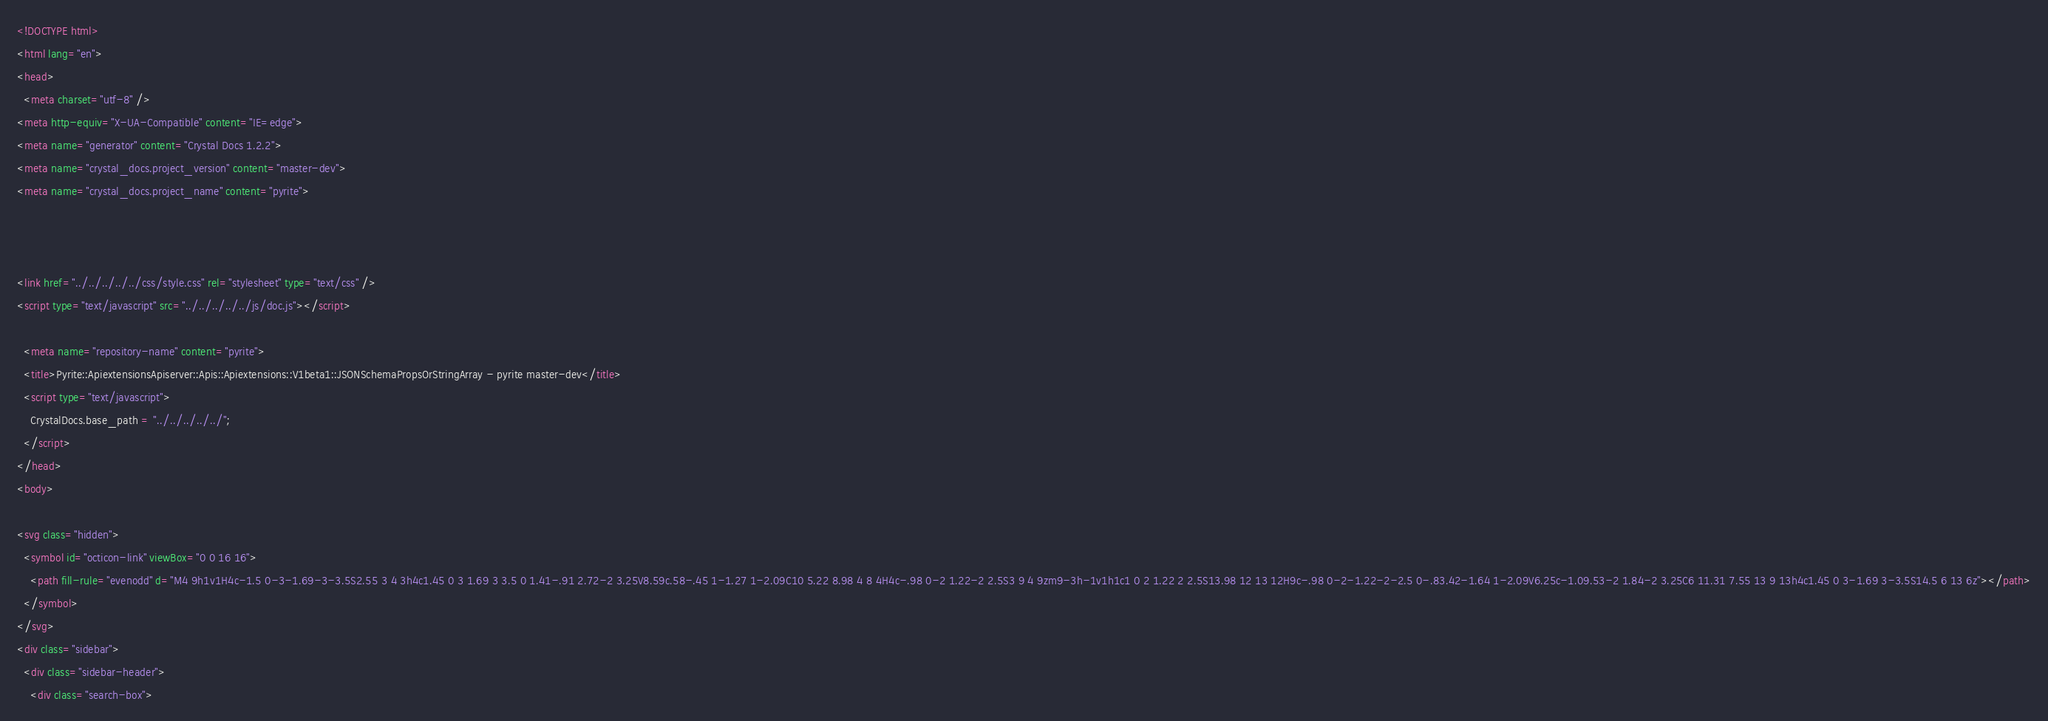Convert code to text. <code><loc_0><loc_0><loc_500><loc_500><_HTML_><!DOCTYPE html>
<html lang="en">
<head>
  <meta charset="utf-8" />
<meta http-equiv="X-UA-Compatible" content="IE=edge">
<meta name="generator" content="Crystal Docs 1.2.2">
<meta name="crystal_docs.project_version" content="master-dev">
<meta name="crystal_docs.project_name" content="pyrite">



<link href="../../../../../css/style.css" rel="stylesheet" type="text/css" />
<script type="text/javascript" src="../../../../../js/doc.js"></script>

  <meta name="repository-name" content="pyrite">
  <title>Pyrite::ApiextensionsApiserver::Apis::Apiextensions::V1beta1::JSONSchemaPropsOrStringArray - pyrite master-dev</title>
  <script type="text/javascript">
    CrystalDocs.base_path = "../../../../../";
  </script>
</head>
<body>

<svg class="hidden">
  <symbol id="octicon-link" viewBox="0 0 16 16">
    <path fill-rule="evenodd" d="M4 9h1v1H4c-1.5 0-3-1.69-3-3.5S2.55 3 4 3h4c1.45 0 3 1.69 3 3.5 0 1.41-.91 2.72-2 3.25V8.59c.58-.45 1-1.27 1-2.09C10 5.22 8.98 4 8 4H4c-.98 0-2 1.22-2 2.5S3 9 4 9zm9-3h-1v1h1c1 0 2 1.22 2 2.5S13.98 12 13 12H9c-.98 0-2-1.22-2-2.5 0-.83.42-1.64 1-2.09V6.25c-1.09.53-2 1.84-2 3.25C6 11.31 7.55 13 9 13h4c1.45 0 3-1.69 3-3.5S14.5 6 13 6z"></path>
  </symbol>
</svg>
<div class="sidebar">
  <div class="sidebar-header">
    <div class="search-box"></code> 